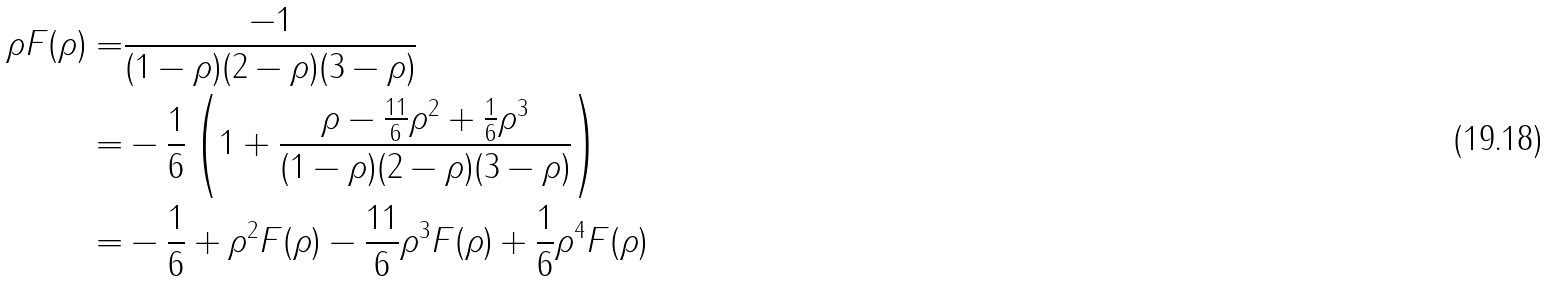<formula> <loc_0><loc_0><loc_500><loc_500>\rho F ( \rho ) = & \frac { - 1 } { ( 1 - \rho ) ( 2 - \rho ) ( 3 - \rho ) } \\ = & - \frac { 1 } { 6 } \left ( 1 + \frac { \rho - \frac { 1 1 } { 6 } \rho ^ { 2 } + \frac { 1 } { 6 } \rho ^ { 3 } } { ( 1 - \rho ) ( 2 - \rho ) ( 3 - \rho ) } \right ) \\ = & - \frac { 1 } { 6 } + \rho ^ { 2 } F ( \rho ) - \frac { 1 1 } { 6 } \rho ^ { 3 } F ( \rho ) + \frac { 1 } { 6 } \rho ^ { 4 } F ( \rho )</formula> 